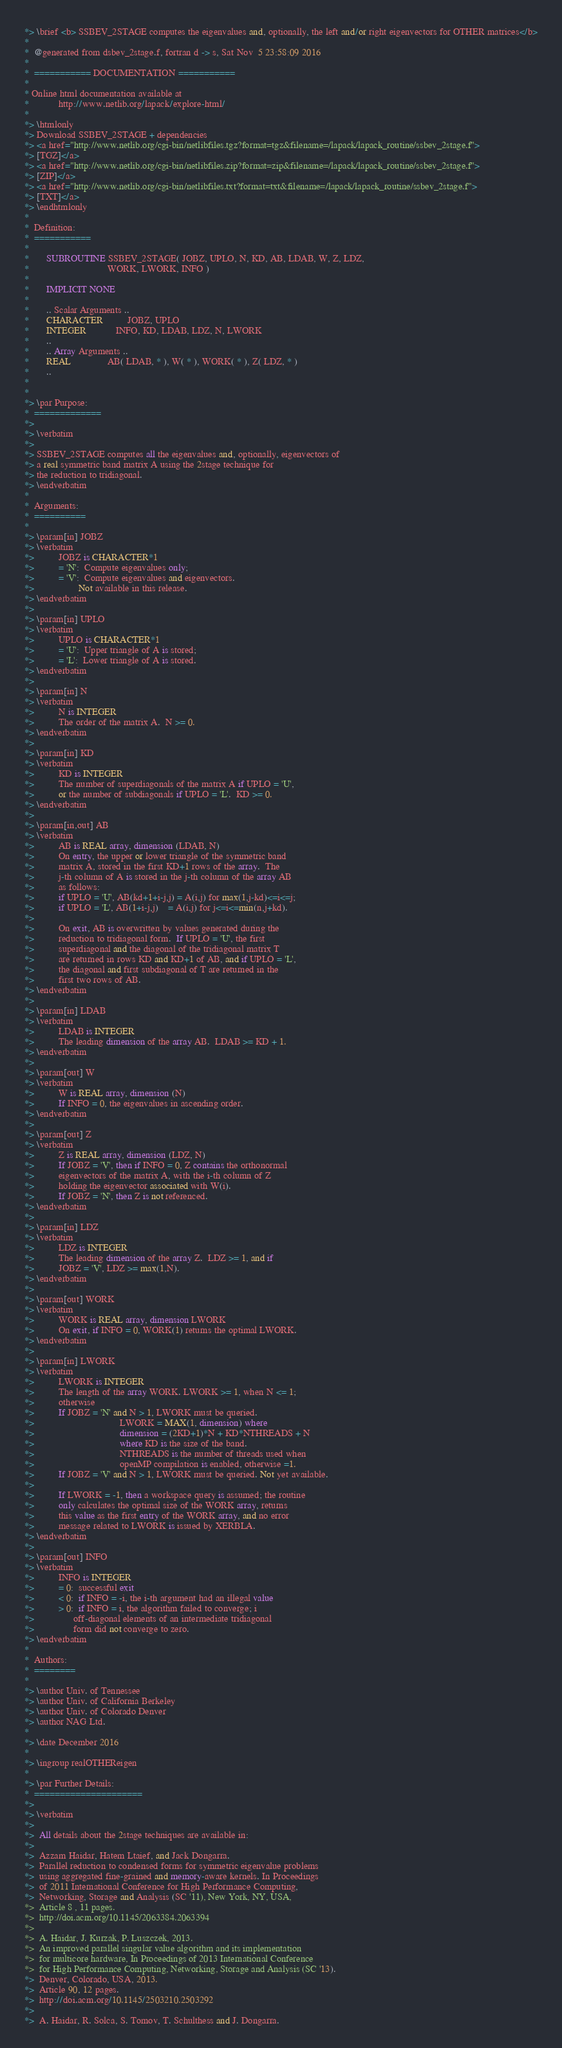Convert code to text. <code><loc_0><loc_0><loc_500><loc_500><_FORTRAN_>*> \brief <b> SSBEV_2STAGE computes the eigenvalues and, optionally, the left and/or right eigenvectors for OTHER matrices</b>
*
*  @generated from dsbev_2stage.f, fortran d -> s, Sat Nov  5 23:58:09 2016
*
*  =========== DOCUMENTATION ===========
*
* Online html documentation available at
*            http://www.netlib.org/lapack/explore-html/
*
*> \htmlonly
*> Download SSBEV_2STAGE + dependencies
*> <a href="http://www.netlib.org/cgi-bin/netlibfiles.tgz?format=tgz&filename=/lapack/lapack_routine/ssbev_2stage.f">
*> [TGZ]</a>
*> <a href="http://www.netlib.org/cgi-bin/netlibfiles.zip?format=zip&filename=/lapack/lapack_routine/ssbev_2stage.f">
*> [ZIP]</a>
*> <a href="http://www.netlib.org/cgi-bin/netlibfiles.txt?format=txt&filename=/lapack/lapack_routine/ssbev_2stage.f">
*> [TXT]</a>
*> \endhtmlonly
*
*  Definition:
*  ===========
*
*       SUBROUTINE SSBEV_2STAGE( JOBZ, UPLO, N, KD, AB, LDAB, W, Z, LDZ,
*                                WORK, LWORK, INFO )
*
*       IMPLICIT NONE
*
*       .. Scalar Arguments ..
*       CHARACTER          JOBZ, UPLO
*       INTEGER            INFO, KD, LDAB, LDZ, N, LWORK
*       ..
*       .. Array Arguments ..
*       REAL               AB( LDAB, * ), W( * ), WORK( * ), Z( LDZ, * )
*       ..
*
*
*> \par Purpose:
*  =============
*>
*> \verbatim
*>
*> SSBEV_2STAGE computes all the eigenvalues and, optionally, eigenvectors of
*> a real symmetric band matrix A using the 2stage technique for
*> the reduction to tridiagonal.
*> \endverbatim
*
*  Arguments:
*  ==========
*
*> \param[in] JOBZ
*> \verbatim
*>          JOBZ is CHARACTER*1
*>          = 'N':  Compute eigenvalues only;
*>          = 'V':  Compute eigenvalues and eigenvectors.
*>                  Not available in this release.
*> \endverbatim
*>
*> \param[in] UPLO
*> \verbatim
*>          UPLO is CHARACTER*1
*>          = 'U':  Upper triangle of A is stored;
*>          = 'L':  Lower triangle of A is stored.
*> \endverbatim
*>
*> \param[in] N
*> \verbatim
*>          N is INTEGER
*>          The order of the matrix A.  N >= 0.
*> \endverbatim
*>
*> \param[in] KD
*> \verbatim
*>          KD is INTEGER
*>          The number of superdiagonals of the matrix A if UPLO = 'U',
*>          or the number of subdiagonals if UPLO = 'L'.  KD >= 0.
*> \endverbatim
*>
*> \param[in,out] AB
*> \verbatim
*>          AB is REAL array, dimension (LDAB, N)
*>          On entry, the upper or lower triangle of the symmetric band
*>          matrix A, stored in the first KD+1 rows of the array.  The
*>          j-th column of A is stored in the j-th column of the array AB
*>          as follows:
*>          if UPLO = 'U', AB(kd+1+i-j,j) = A(i,j) for max(1,j-kd)<=i<=j;
*>          if UPLO = 'L', AB(1+i-j,j)    = A(i,j) for j<=i<=min(n,j+kd).
*>
*>          On exit, AB is overwritten by values generated during the
*>          reduction to tridiagonal form.  If UPLO = 'U', the first
*>          superdiagonal and the diagonal of the tridiagonal matrix T
*>          are returned in rows KD and KD+1 of AB, and if UPLO = 'L',
*>          the diagonal and first subdiagonal of T are returned in the
*>          first two rows of AB.
*> \endverbatim
*>
*> \param[in] LDAB
*> \verbatim
*>          LDAB is INTEGER
*>          The leading dimension of the array AB.  LDAB >= KD + 1.
*> \endverbatim
*>
*> \param[out] W
*> \verbatim
*>          W is REAL array, dimension (N)
*>          If INFO = 0, the eigenvalues in ascending order.
*> \endverbatim
*>
*> \param[out] Z
*> \verbatim
*>          Z is REAL array, dimension (LDZ, N)
*>          If JOBZ = 'V', then if INFO = 0, Z contains the orthonormal
*>          eigenvectors of the matrix A, with the i-th column of Z
*>          holding the eigenvector associated with W(i).
*>          If JOBZ = 'N', then Z is not referenced.
*> \endverbatim
*>
*> \param[in] LDZ
*> \verbatim
*>          LDZ is INTEGER
*>          The leading dimension of the array Z.  LDZ >= 1, and if
*>          JOBZ = 'V', LDZ >= max(1,N).
*> \endverbatim
*>
*> \param[out] WORK
*> \verbatim
*>          WORK is REAL array, dimension LWORK
*>          On exit, if INFO = 0, WORK(1) returns the optimal LWORK.
*> \endverbatim
*>
*> \param[in] LWORK
*> \verbatim
*>          LWORK is INTEGER
*>          The length of the array WORK. LWORK >= 1, when N <= 1;
*>          otherwise  
*>          If JOBZ = 'N' and N > 1, LWORK must be queried.
*>                                   LWORK = MAX(1, dimension) where
*>                                   dimension = (2KD+1)*N + KD*NTHREADS + N
*>                                   where KD is the size of the band.
*>                                   NTHREADS is the number of threads used when
*>                                   openMP compilation is enabled, otherwise =1.
*>          If JOBZ = 'V' and N > 1, LWORK must be queried. Not yet available.
*>
*>          If LWORK = -1, then a workspace query is assumed; the routine
*>          only calculates the optimal size of the WORK array, returns
*>          this value as the first entry of the WORK array, and no error
*>          message related to LWORK is issued by XERBLA.
*> \endverbatim
*>
*> \param[out] INFO
*> \verbatim
*>          INFO is INTEGER
*>          = 0:  successful exit
*>          < 0:  if INFO = -i, the i-th argument had an illegal value
*>          > 0:  if INFO = i, the algorithm failed to converge; i
*>                off-diagonal elements of an intermediate tridiagonal
*>                form did not converge to zero.
*> \endverbatim
*
*  Authors:
*  ========
*
*> \author Univ. of Tennessee
*> \author Univ. of California Berkeley
*> \author Univ. of Colorado Denver
*> \author NAG Ltd.
*
*> \date December 2016
*
*> \ingroup realOTHEReigen
*
*> \par Further Details:
*  =====================
*>
*> \verbatim
*>
*>  All details about the 2stage techniques are available in:
*>
*>  Azzam Haidar, Hatem Ltaief, and Jack Dongarra.
*>  Parallel reduction to condensed forms for symmetric eigenvalue problems
*>  using aggregated fine-grained and memory-aware kernels. In Proceedings
*>  of 2011 International Conference for High Performance Computing,
*>  Networking, Storage and Analysis (SC '11), New York, NY, USA,
*>  Article 8 , 11 pages.
*>  http://doi.acm.org/10.1145/2063384.2063394
*>
*>  A. Haidar, J. Kurzak, P. Luszczek, 2013.
*>  An improved parallel singular value algorithm and its implementation 
*>  for multicore hardware, In Proceedings of 2013 International Conference
*>  for High Performance Computing, Networking, Storage and Analysis (SC '13).
*>  Denver, Colorado, USA, 2013.
*>  Article 90, 12 pages.
*>  http://doi.acm.org/10.1145/2503210.2503292
*>
*>  A. Haidar, R. Solca, S. Tomov, T. Schulthess and J. Dongarra.</code> 